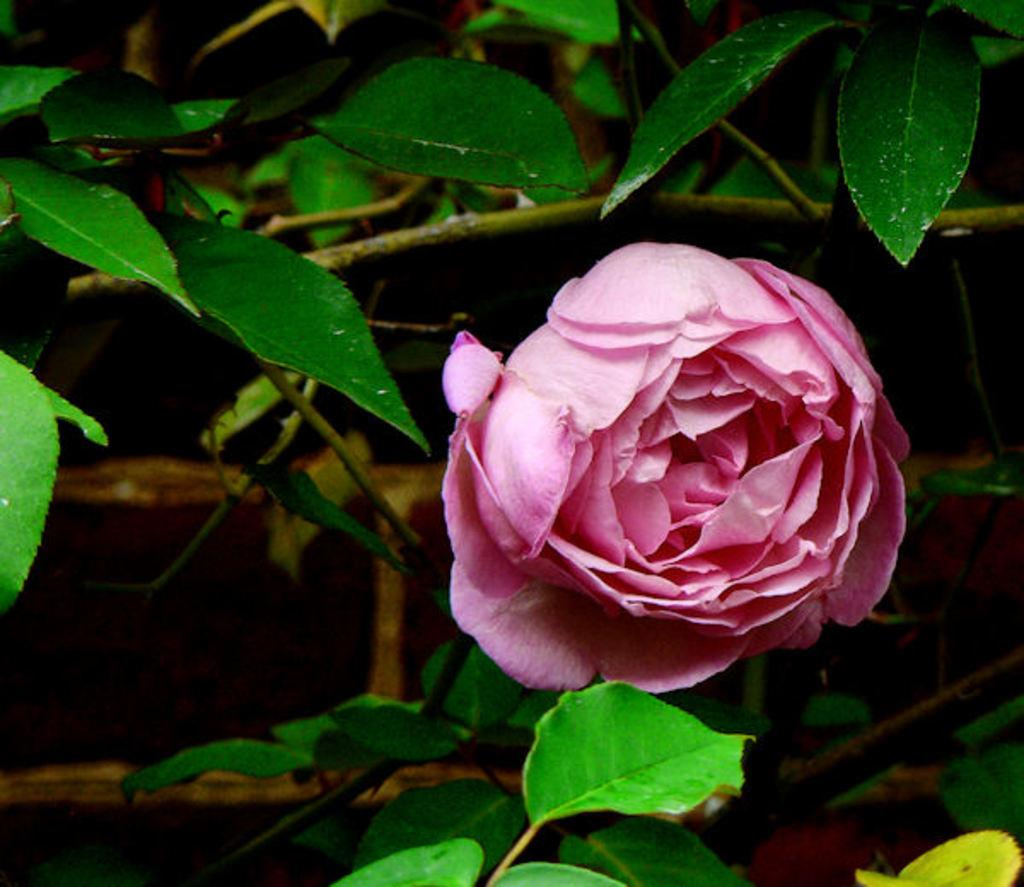What is the focus of the zoomed-in picture? The subject of the image is a pink color flower. What can be inferred about the flower from the image? The flower is part of a plant. What type of battle is taking place in the background of the image? There is no battle present in the image; it is a close-up of a pink color flower. Are there any bushes visible in the image? The image is a zoomed-in picture of a pink color flower, so it is not possible to see any bushes in the image. 